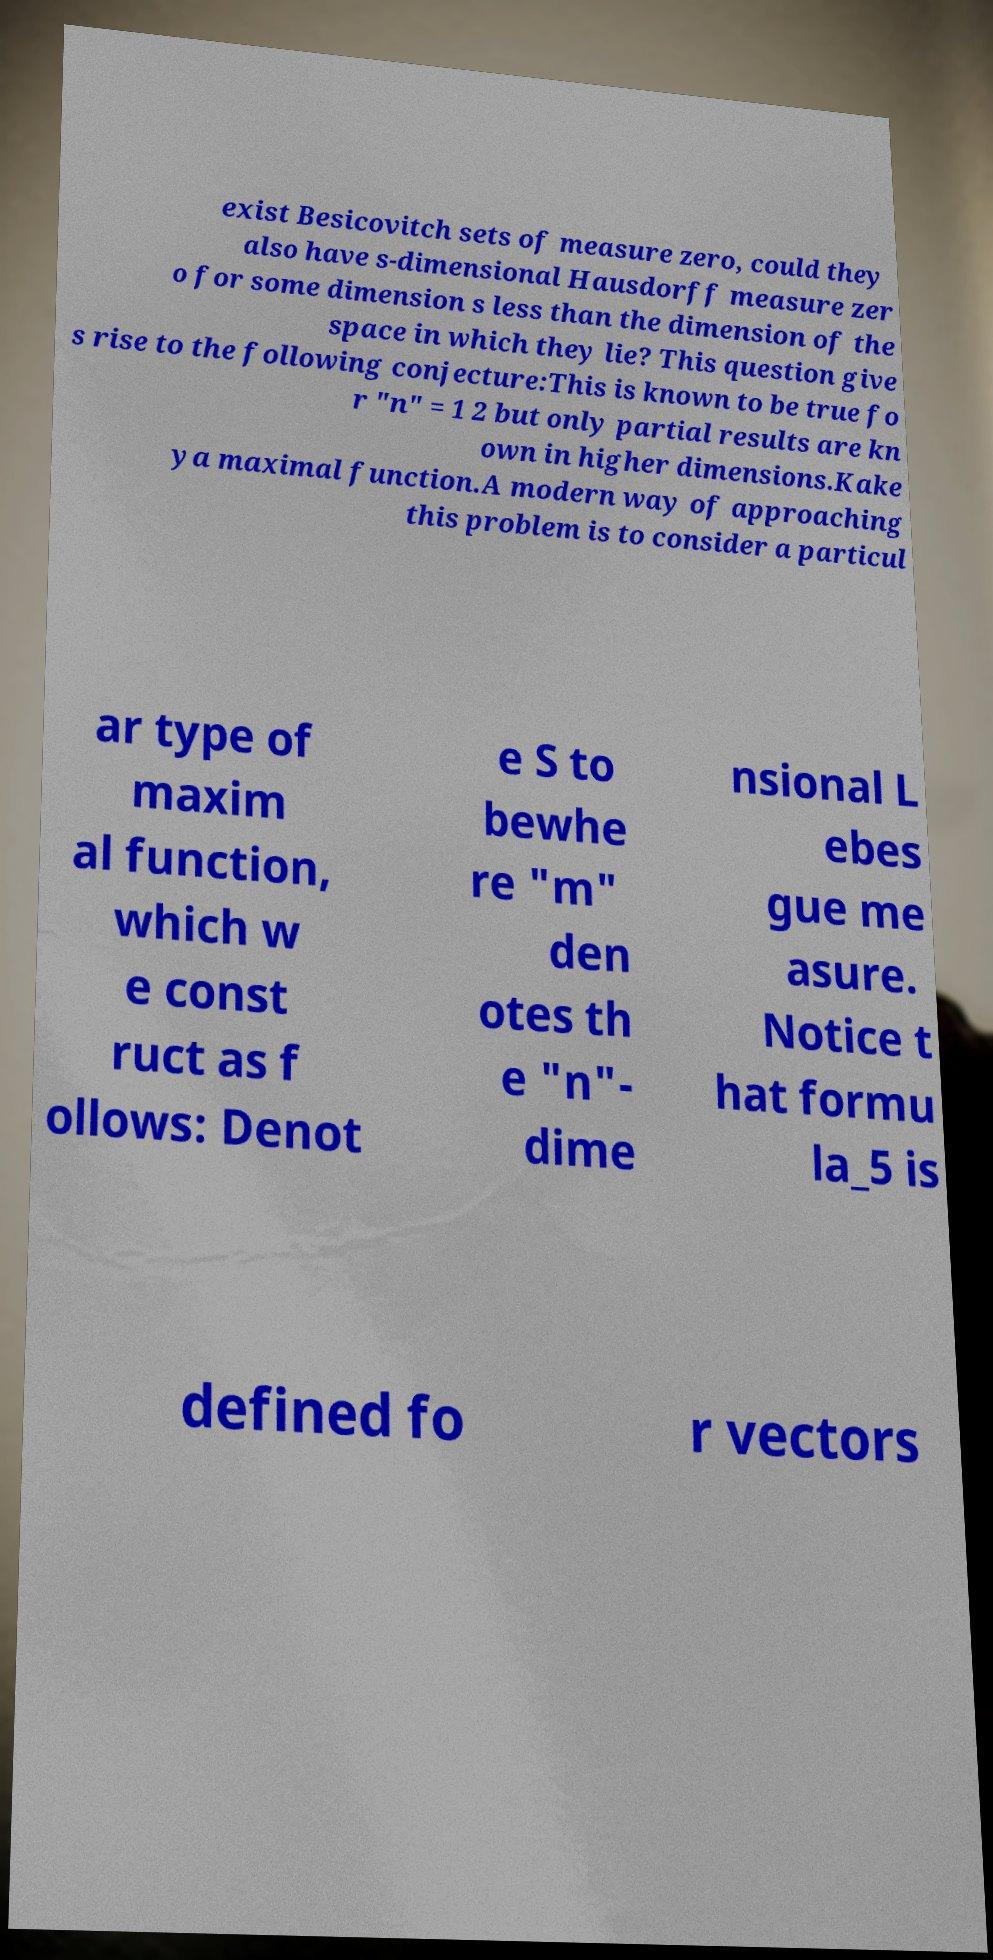There's text embedded in this image that I need extracted. Can you transcribe it verbatim? exist Besicovitch sets of measure zero, could they also have s-dimensional Hausdorff measure zer o for some dimension s less than the dimension of the space in which they lie? This question give s rise to the following conjecture:This is known to be true fo r "n" = 1 2 but only partial results are kn own in higher dimensions.Kake ya maximal function.A modern way of approaching this problem is to consider a particul ar type of maxim al function, which w e const ruct as f ollows: Denot e S to bewhe re "m" den otes th e "n"- dime nsional L ebes gue me asure. Notice t hat formu la_5 is defined fo r vectors 